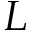<formula> <loc_0><loc_0><loc_500><loc_500>L</formula> 